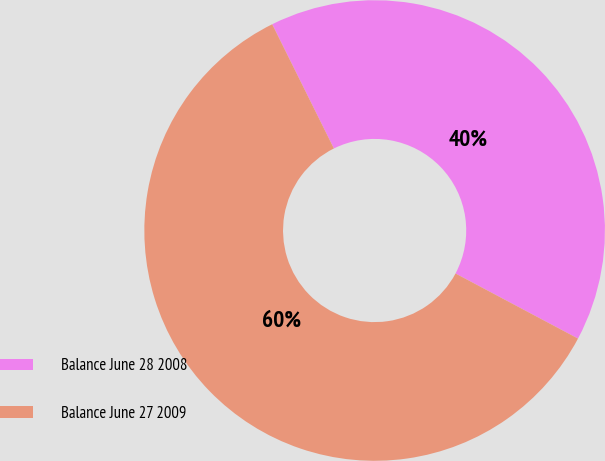<chart> <loc_0><loc_0><loc_500><loc_500><pie_chart><fcel>Balance June 28 2008<fcel>Balance June 27 2009<nl><fcel>40.11%<fcel>59.89%<nl></chart> 